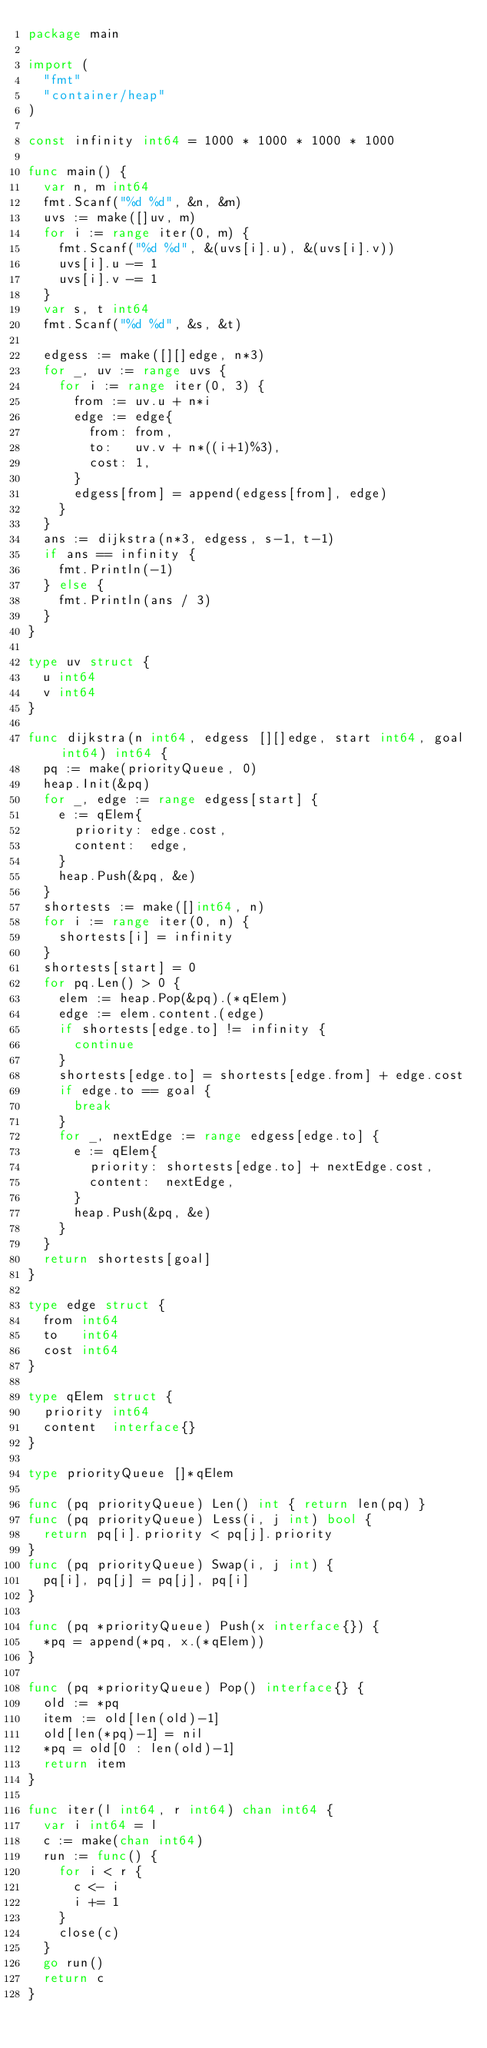Convert code to text. <code><loc_0><loc_0><loc_500><loc_500><_Go_>package main

import (
	"fmt"
	"container/heap"
)

const infinity int64 = 1000 * 1000 * 1000 * 1000

func main() {
	var n, m int64
	fmt.Scanf("%d %d", &n, &m)
	uvs := make([]uv, m)
	for i := range iter(0, m) {
		fmt.Scanf("%d %d", &(uvs[i].u), &(uvs[i].v))
		uvs[i].u -= 1
		uvs[i].v -= 1
	}
	var s, t int64
	fmt.Scanf("%d %d", &s, &t)

	edgess := make([][]edge, n*3)
	for _, uv := range uvs {
		for i := range iter(0, 3) {
			from := uv.u + n*i
			edge := edge{
				from: from,
				to:   uv.v + n*((i+1)%3),
				cost: 1,
			}
			edgess[from] = append(edgess[from], edge)
		}
	}
	ans := dijkstra(n*3, edgess, s-1, t-1)
	if ans == infinity {
		fmt.Println(-1)
	} else {
		fmt.Println(ans / 3)
	}
}

type uv struct {
	u int64
	v int64
}

func dijkstra(n int64, edgess [][]edge, start int64, goal int64) int64 {
	pq := make(priorityQueue, 0)
	heap.Init(&pq)
	for _, edge := range edgess[start] {
		e := qElem{
			priority: edge.cost,
			content:  edge,
		}
		heap.Push(&pq, &e)
	}
	shortests := make([]int64, n)
	for i := range iter(0, n) {
		shortests[i] = infinity
	}
	shortests[start] = 0
	for pq.Len() > 0 {
		elem := heap.Pop(&pq).(*qElem)
		edge := elem.content.(edge)
		if shortests[edge.to] != infinity {
			continue
		}
		shortests[edge.to] = shortests[edge.from] + edge.cost
		if edge.to == goal {
			break
		}
		for _, nextEdge := range edgess[edge.to] {
			e := qElem{
				priority: shortests[edge.to] + nextEdge.cost,
				content:  nextEdge,
			}
			heap.Push(&pq, &e)
		}
	}
	return shortests[goal]
}

type edge struct {
	from int64
	to   int64
	cost int64
}

type qElem struct {
	priority int64
	content  interface{}
}

type priorityQueue []*qElem

func (pq priorityQueue) Len() int { return len(pq) }
func (pq priorityQueue) Less(i, j int) bool {
	return pq[i].priority < pq[j].priority
}
func (pq priorityQueue) Swap(i, j int) {
	pq[i], pq[j] = pq[j], pq[i]
}

func (pq *priorityQueue) Push(x interface{}) {
	*pq = append(*pq, x.(*qElem))
}

func (pq *priorityQueue) Pop() interface{} {
	old := *pq
	item := old[len(old)-1]
	old[len(*pq)-1] = nil
	*pq = old[0 : len(old)-1]
	return item
}

func iter(l int64, r int64) chan int64 {
	var i int64 = l
	c := make(chan int64)
	run := func() {
		for i < r {
			c <- i
			i += 1
		}
		close(c)
	}
	go run()
	return c
}
</code> 